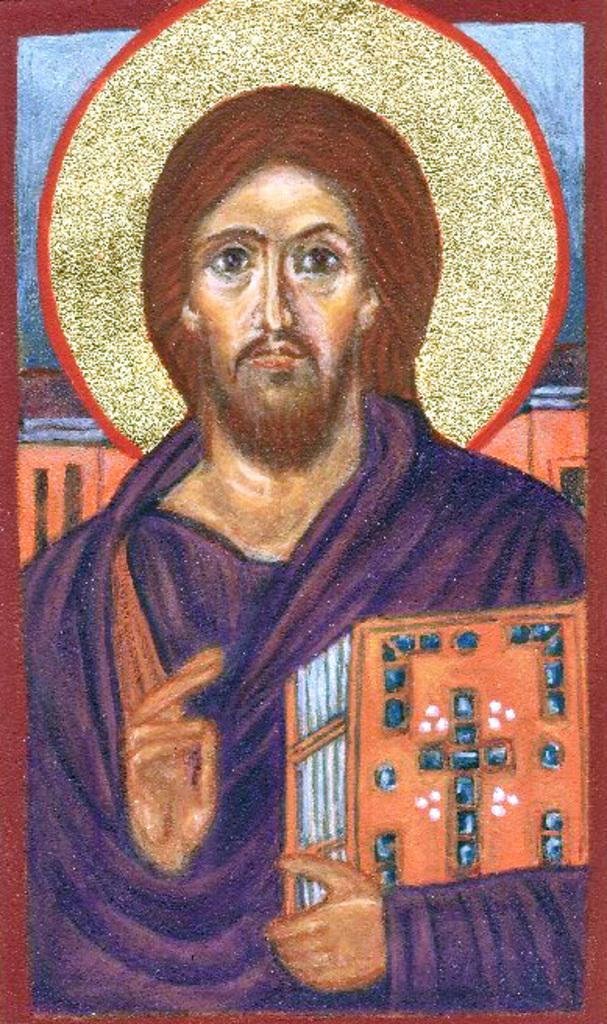What is the main subject of the image? There is a painting in the image. What does the painting depict? The painting depicts a man. What is the man holding in the painting? The man is holding a book in his hand. What does the painting smell like in the image? Paintings do not have a smell, so this question cannot be answered based on the image. 